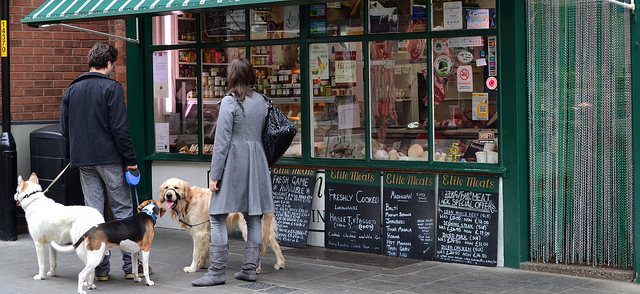Can you make any observations about the types of products on offer at the store? The chalkboards list various items, indicating that the shop offers a range of meat products such as venison, pheasant, and rabbit, along with prepared foods like sausages and meat pies. This suggests that the store specializes in a variety of meats, which may be fresh and locally sourced, appealing to customers seeking different kinds of meat products beyond what is typically found in a supermarket. 
Is there anything in the image that suggests the time of year or day? There is no direct indication of the specific time of year or day in the image. The people are wearing light jackets, which could suggest that the weather is mild, likely either spring or autumn. The daylight and the open shop suggest it is daytime, but without shadows or the position of the sun, it is difficult to determine the exact time of day. The absence of holiday decorations or summer attire indicates that it is neither the peak of summer nor a holiday season. 